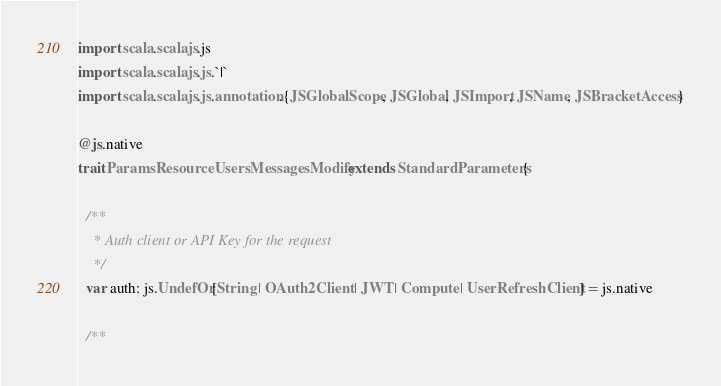Convert code to text. <code><loc_0><loc_0><loc_500><loc_500><_Scala_>import scala.scalajs.js
import scala.scalajs.js.`|`
import scala.scalajs.js.annotation.{JSGlobalScope, JSGlobal, JSImport, JSName, JSBracketAccess}

@js.native
trait ParamsResourceUsersMessagesModify extends StandardParameters {
  
  /**
    * Auth client or API Key for the request
    */
  var auth: js.UndefOr[String | OAuth2Client | JWT | Compute | UserRefreshClient] = js.native
  
  /**</code> 